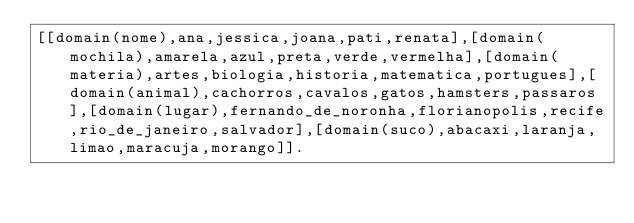Convert code to text. <code><loc_0><loc_0><loc_500><loc_500><_Prolog_>[[domain(nome),ana,jessica,joana,pati,renata],[domain(mochila),amarela,azul,preta,verde,vermelha],[domain(materia),artes,biologia,historia,matematica,portugues],[domain(animal),cachorros,cavalos,gatos,hamsters,passaros],[domain(lugar),fernando_de_noronha,florianopolis,recife,rio_de_janeiro,salvador],[domain(suco),abacaxi,laranja,limao,maracuja,morango]].</code> 